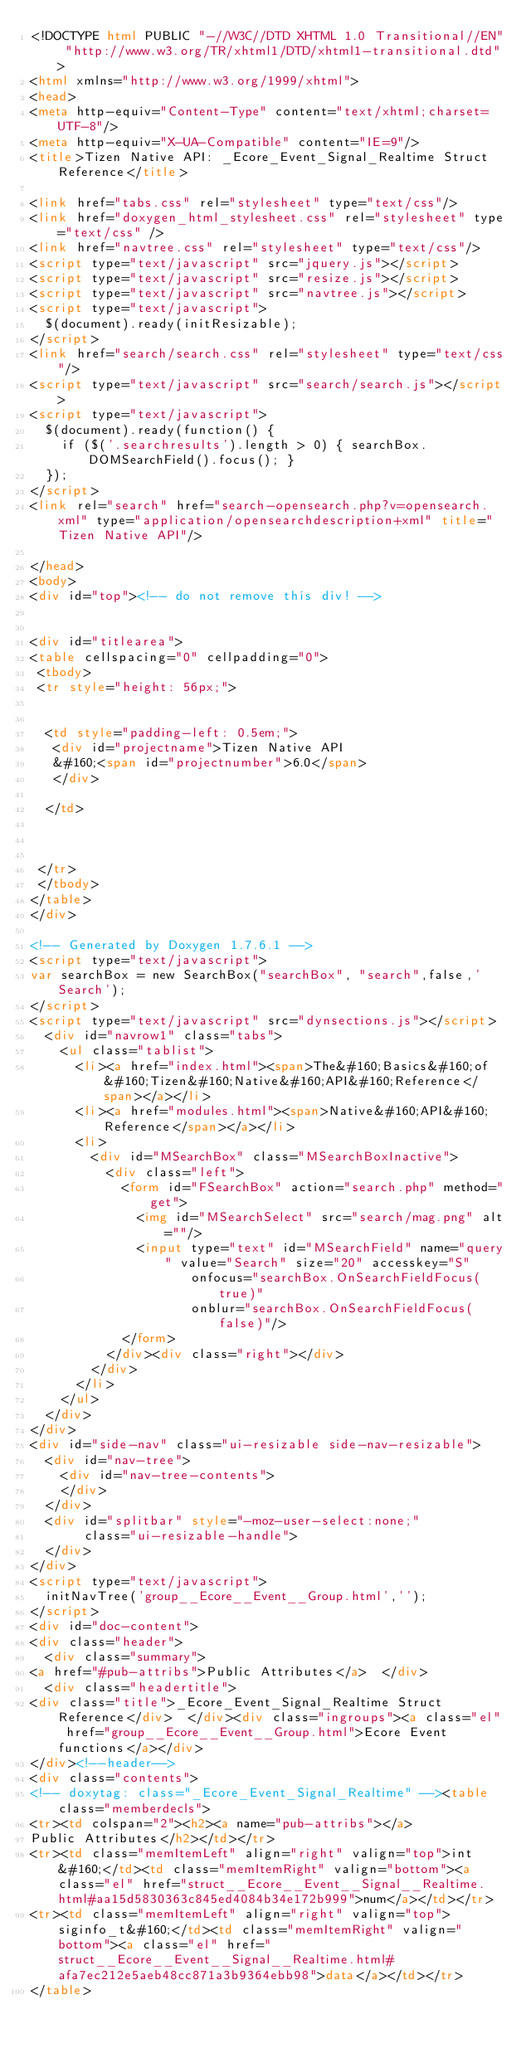Convert code to text. <code><loc_0><loc_0><loc_500><loc_500><_HTML_><!DOCTYPE html PUBLIC "-//W3C//DTD XHTML 1.0 Transitional//EN" "http://www.w3.org/TR/xhtml1/DTD/xhtml1-transitional.dtd">
<html xmlns="http://www.w3.org/1999/xhtml">
<head>
<meta http-equiv="Content-Type" content="text/xhtml;charset=UTF-8"/>
<meta http-equiv="X-UA-Compatible" content="IE=9"/>
<title>Tizen Native API: _Ecore_Event_Signal_Realtime Struct Reference</title>

<link href="tabs.css" rel="stylesheet" type="text/css"/>
<link href="doxygen_html_stylesheet.css" rel="stylesheet" type="text/css" />
<link href="navtree.css" rel="stylesheet" type="text/css"/>
<script type="text/javascript" src="jquery.js"></script>
<script type="text/javascript" src="resize.js"></script>
<script type="text/javascript" src="navtree.js"></script>
<script type="text/javascript">
  $(document).ready(initResizable);
</script>
<link href="search/search.css" rel="stylesheet" type="text/css"/>
<script type="text/javascript" src="search/search.js"></script>
<script type="text/javascript">
  $(document).ready(function() {
    if ($('.searchresults').length > 0) { searchBox.DOMSearchField().focus(); }
  });
</script>
<link rel="search" href="search-opensearch.php?v=opensearch.xml" type="application/opensearchdescription+xml" title="Tizen Native API"/>

</head>
<body>
<div id="top"><!-- do not remove this div! -->


<div id="titlearea">
<table cellspacing="0" cellpadding="0">
 <tbody>
 <tr style="height: 56px;">
  
  
  <td style="padding-left: 0.5em;">
   <div id="projectname">Tizen Native API
   &#160;<span id="projectnumber">6.0</span>
   </div>
   
  </td>
  
  
  
 </tr>
 </tbody>
</table>
</div>

<!-- Generated by Doxygen 1.7.6.1 -->
<script type="text/javascript">
var searchBox = new SearchBox("searchBox", "search",false,'Search');
</script>
<script type="text/javascript" src="dynsections.js"></script>
  <div id="navrow1" class="tabs">
    <ul class="tablist">
      <li><a href="index.html"><span>The&#160;Basics&#160;of&#160;Tizen&#160;Native&#160;API&#160;Reference</span></a></li>
      <li><a href="modules.html"><span>Native&#160;API&#160;Reference</span></a></li>
      <li>
        <div id="MSearchBox" class="MSearchBoxInactive">
          <div class="left">
            <form id="FSearchBox" action="search.php" method="get">
              <img id="MSearchSelect" src="search/mag.png" alt=""/>
              <input type="text" id="MSearchField" name="query" value="Search" size="20" accesskey="S" 
                     onfocus="searchBox.OnSearchFieldFocus(true)" 
                     onblur="searchBox.OnSearchFieldFocus(false)"/>
            </form>
          </div><div class="right"></div>
        </div>
      </li>
    </ul>
  </div>
</div>
<div id="side-nav" class="ui-resizable side-nav-resizable">
  <div id="nav-tree">
    <div id="nav-tree-contents">
    </div>
  </div>
  <div id="splitbar" style="-moz-user-select:none;" 
       class="ui-resizable-handle">
  </div>
</div>
<script type="text/javascript">
  initNavTree('group__Ecore__Event__Group.html','');
</script>
<div id="doc-content">
<div class="header">
  <div class="summary">
<a href="#pub-attribs">Public Attributes</a>  </div>
  <div class="headertitle">
<div class="title">_Ecore_Event_Signal_Realtime Struct Reference</div>  </div><div class="ingroups"><a class="el" href="group__Ecore__Event__Group.html">Ecore Event functions</a></div>
</div><!--header-->
<div class="contents">
<!-- doxytag: class="_Ecore_Event_Signal_Realtime" --><table class="memberdecls">
<tr><td colspan="2"><h2><a name="pub-attribs"></a>
Public Attributes</h2></td></tr>
<tr><td class="memItemLeft" align="right" valign="top">int&#160;</td><td class="memItemRight" valign="bottom"><a class="el" href="struct__Ecore__Event__Signal__Realtime.html#aa15d5830363c845ed4084b34e172b999">num</a></td></tr>
<tr><td class="memItemLeft" align="right" valign="top">siginfo_t&#160;</td><td class="memItemRight" valign="bottom"><a class="el" href="struct__Ecore__Event__Signal__Realtime.html#afa7ec212e5aeb48cc871a3b9364ebb98">data</a></td></tr>
</table></code> 